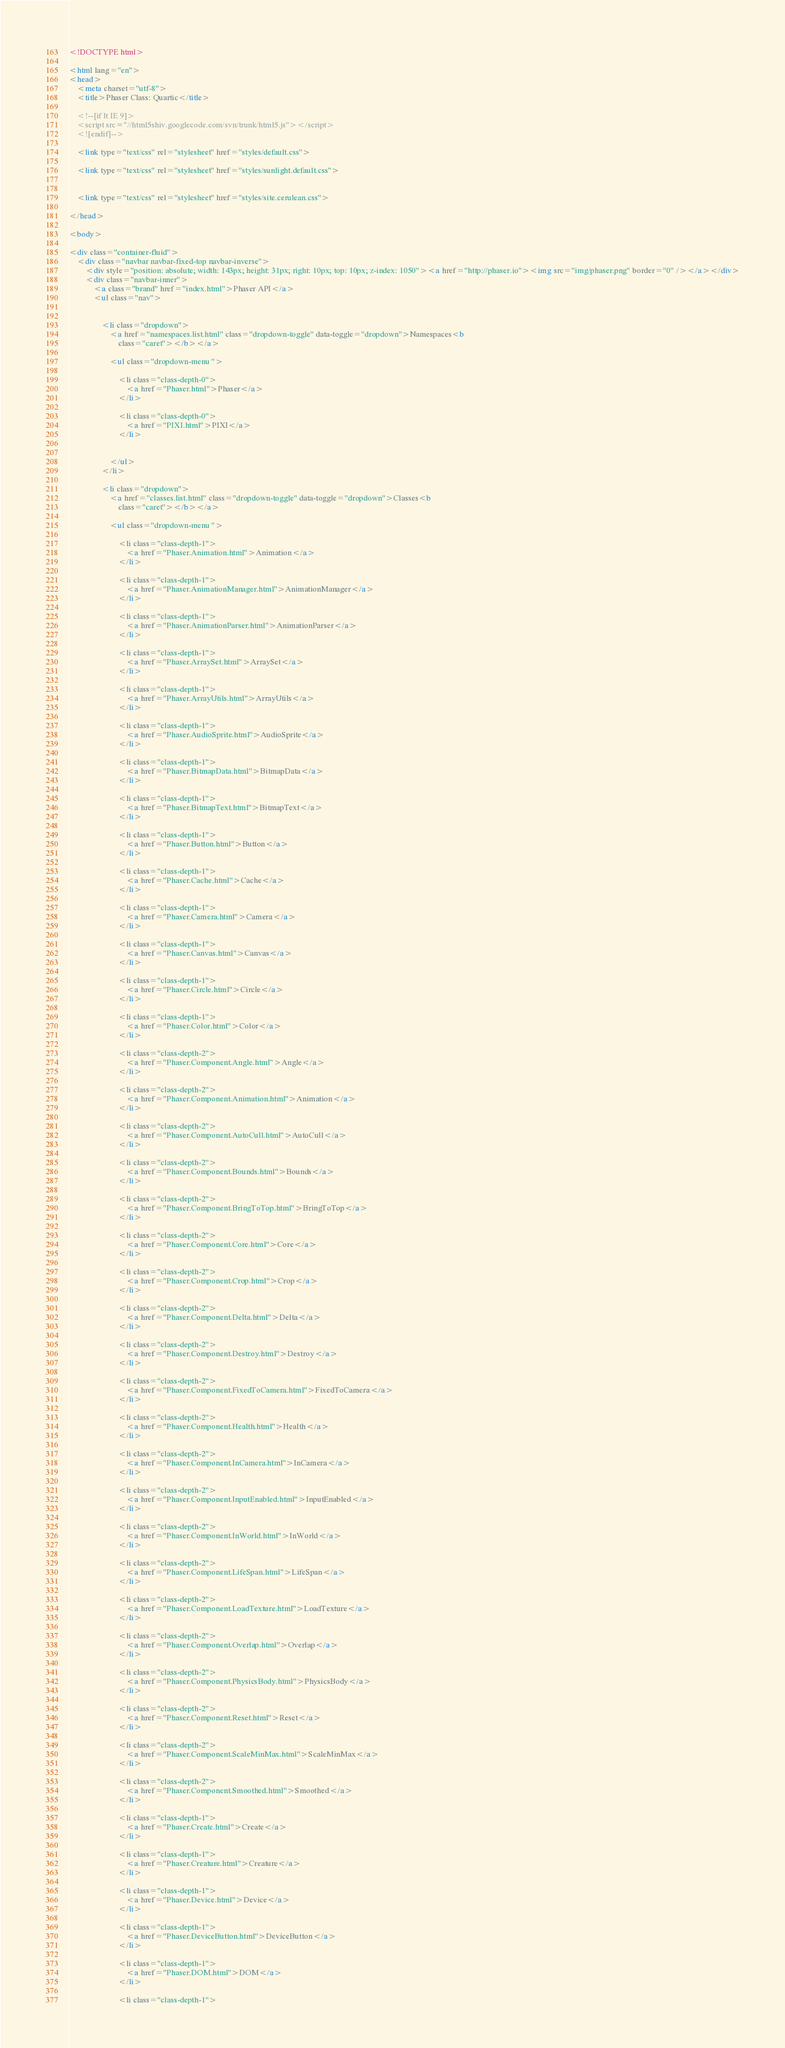Convert code to text. <code><loc_0><loc_0><loc_500><loc_500><_HTML_><!DOCTYPE html>

<html lang="en">
<head>
	<meta charset="utf-8">
	<title>Phaser Class: Quartic</title>

	<!--[if lt IE 9]>
	<script src="//html5shiv.googlecode.com/svn/trunk/html5.js"></script>
	<![endif]-->

	<link type="text/css" rel="stylesheet" href="styles/default.css">

	<link type="text/css" rel="stylesheet" href="styles/sunlight.default.css">

	
	<link type="text/css" rel="stylesheet" href="styles/site.cerulean.css">
	
</head>

<body>

<div class="container-fluid">
	<div class="navbar navbar-fixed-top navbar-inverse">
		<div style="position: absolute; width: 143px; height: 31px; right: 10px; top: 10px; z-index: 1050"><a href="http://phaser.io"><img src="img/phaser.png" border="0" /></a></div>
		<div class="navbar-inner">
			<a class="brand" href="index.html">Phaser API</a>
			<ul class="nav">

				
				<li class="dropdown">
					<a href="namespaces.list.html" class="dropdown-toggle" data-toggle="dropdown">Namespaces<b
						class="caret"></b></a>

					<ul class="dropdown-menu ">
						
						<li class="class-depth-0">
							<a href="Phaser.html">Phaser</a>
						</li>
						
						<li class="class-depth-0">
							<a href="PIXI.html">PIXI</a>
						</li>
						

					</ul>
				</li>
				
				<li class="dropdown">
					<a href="classes.list.html" class="dropdown-toggle" data-toggle="dropdown">Classes<b
						class="caret"></b></a>

					<ul class="dropdown-menu ">
						
						<li class="class-depth-1">
							<a href="Phaser.Animation.html">Animation</a>
						</li>
						
						<li class="class-depth-1">
							<a href="Phaser.AnimationManager.html">AnimationManager</a>
						</li>
						
						<li class="class-depth-1">
							<a href="Phaser.AnimationParser.html">AnimationParser</a>
						</li>
						
						<li class="class-depth-1">
							<a href="Phaser.ArraySet.html">ArraySet</a>
						</li>
						
						<li class="class-depth-1">
							<a href="Phaser.ArrayUtils.html">ArrayUtils</a>
						</li>
						
						<li class="class-depth-1">
							<a href="Phaser.AudioSprite.html">AudioSprite</a>
						</li>
						
						<li class="class-depth-1">
							<a href="Phaser.BitmapData.html">BitmapData</a>
						</li>
						
						<li class="class-depth-1">
							<a href="Phaser.BitmapText.html">BitmapText</a>
						</li>
						
						<li class="class-depth-1">
							<a href="Phaser.Button.html">Button</a>
						</li>
						
						<li class="class-depth-1">
							<a href="Phaser.Cache.html">Cache</a>
						</li>
						
						<li class="class-depth-1">
							<a href="Phaser.Camera.html">Camera</a>
						</li>
						
						<li class="class-depth-1">
							<a href="Phaser.Canvas.html">Canvas</a>
						</li>
						
						<li class="class-depth-1">
							<a href="Phaser.Circle.html">Circle</a>
						</li>
						
						<li class="class-depth-1">
							<a href="Phaser.Color.html">Color</a>
						</li>
						
						<li class="class-depth-2">
							<a href="Phaser.Component.Angle.html">Angle</a>
						</li>
						
						<li class="class-depth-2">
							<a href="Phaser.Component.Animation.html">Animation</a>
						</li>
						
						<li class="class-depth-2">
							<a href="Phaser.Component.AutoCull.html">AutoCull</a>
						</li>
						
						<li class="class-depth-2">
							<a href="Phaser.Component.Bounds.html">Bounds</a>
						</li>
						
						<li class="class-depth-2">
							<a href="Phaser.Component.BringToTop.html">BringToTop</a>
						</li>
						
						<li class="class-depth-2">
							<a href="Phaser.Component.Core.html">Core</a>
						</li>
						
						<li class="class-depth-2">
							<a href="Phaser.Component.Crop.html">Crop</a>
						</li>
						
						<li class="class-depth-2">
							<a href="Phaser.Component.Delta.html">Delta</a>
						</li>
						
						<li class="class-depth-2">
							<a href="Phaser.Component.Destroy.html">Destroy</a>
						</li>
						
						<li class="class-depth-2">
							<a href="Phaser.Component.FixedToCamera.html">FixedToCamera</a>
						</li>
						
						<li class="class-depth-2">
							<a href="Phaser.Component.Health.html">Health</a>
						</li>
						
						<li class="class-depth-2">
							<a href="Phaser.Component.InCamera.html">InCamera</a>
						</li>
						
						<li class="class-depth-2">
							<a href="Phaser.Component.InputEnabled.html">InputEnabled</a>
						</li>
						
						<li class="class-depth-2">
							<a href="Phaser.Component.InWorld.html">InWorld</a>
						</li>
						
						<li class="class-depth-2">
							<a href="Phaser.Component.LifeSpan.html">LifeSpan</a>
						</li>
						
						<li class="class-depth-2">
							<a href="Phaser.Component.LoadTexture.html">LoadTexture</a>
						</li>
						
						<li class="class-depth-2">
							<a href="Phaser.Component.Overlap.html">Overlap</a>
						</li>
						
						<li class="class-depth-2">
							<a href="Phaser.Component.PhysicsBody.html">PhysicsBody</a>
						</li>
						
						<li class="class-depth-2">
							<a href="Phaser.Component.Reset.html">Reset</a>
						</li>
						
						<li class="class-depth-2">
							<a href="Phaser.Component.ScaleMinMax.html">ScaleMinMax</a>
						</li>
						
						<li class="class-depth-2">
							<a href="Phaser.Component.Smoothed.html">Smoothed</a>
						</li>
						
						<li class="class-depth-1">
							<a href="Phaser.Create.html">Create</a>
						</li>
						
						<li class="class-depth-1">
							<a href="Phaser.Creature.html">Creature</a>
						</li>
						
						<li class="class-depth-1">
							<a href="Phaser.Device.html">Device</a>
						</li>
						
						<li class="class-depth-1">
							<a href="Phaser.DeviceButton.html">DeviceButton</a>
						</li>
						
						<li class="class-depth-1">
							<a href="Phaser.DOM.html">DOM</a>
						</li>
						
						<li class="class-depth-1"></code> 